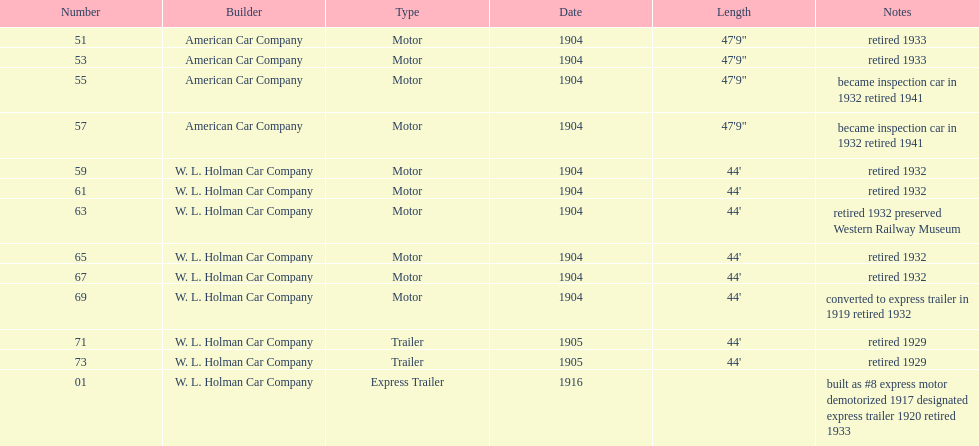In 1906, what was the total number of rolling stock vehicles in operation? 12. 